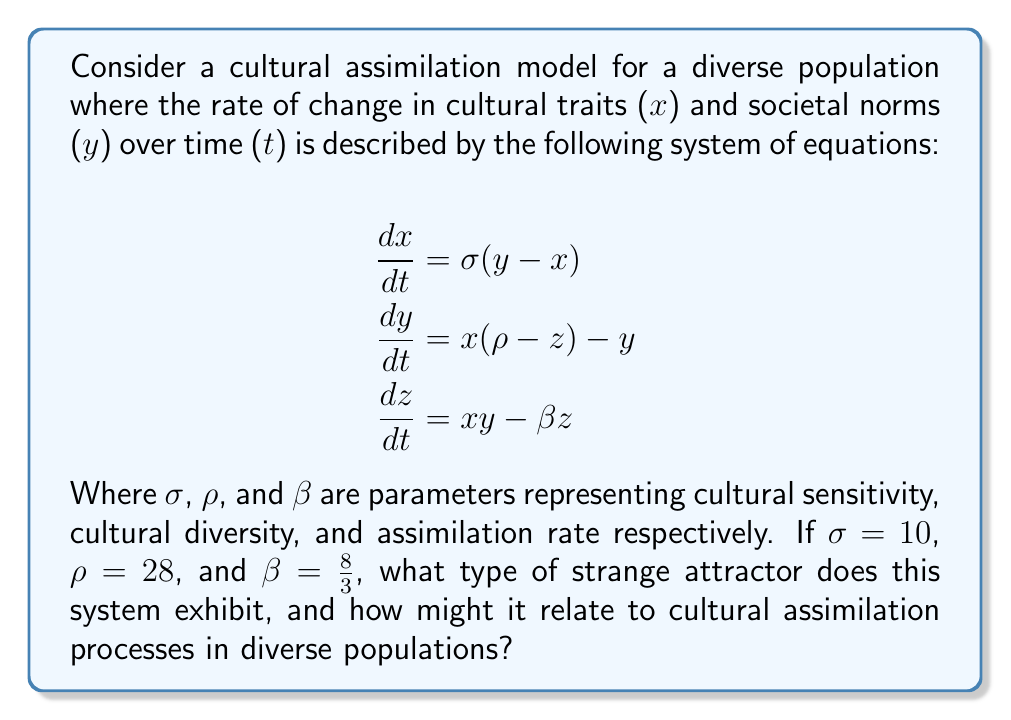Teach me how to tackle this problem. To identify the strange attractor and its relation to cultural assimilation, we need to follow these steps:

1) Recognize the system of equations:
   The given equations are identical to the Lorenz system, which is known to produce a strange attractor under certain parameter conditions.

2) Analyze the parameters:
   The values given ($\sigma = 10$, $\rho = 28$, $\beta = \frac{8}{3}$) are the classic parameters that produce the Lorenz attractor.

3) Understand the Lorenz attractor:
   The Lorenz attractor is a set of chaotic solutions of the Lorenz system which, when plotted, resemble a butterfly or figure-eight pattern.

4) Relate to cultural assimilation:
   In this context:
   - $x$ represents cultural traits
   - $y$ represents societal norms
   - $z$ could represent the degree of cultural integration

   The butterfly-like pattern of the Lorenz attractor suggests that:
   a) The cultural assimilation process is highly sensitive to initial conditions (butterfly effect).
   b) There are two main "wings" which could represent two dominant cultural states or norms.
   c) The system never settles into a steady state, indicating ongoing cultural dynamics and change.
   d) Transitions between the two wings occur unpredictably, which could represent sudden shifts in cultural trends or norms.

5) Implications for cross-cultural studies:
   This model suggests that cultural assimilation is not a linear process, but rather a complex, dynamic system with:
   - Unpredictable long-term outcomes
   - Periods of relative stability (orbiting within one wing) followed by rapid changes (switching wings)
   - Sensitive dependence on initial conditions, emphasizing the importance of accurate data collection and translation in cross-cultural studies

Therefore, this system exhibits the Lorenz attractor, which in the context of cultural assimilation, represents a complex, non-linear process of cultural dynamics in diverse populations.
Answer: Lorenz attractor 